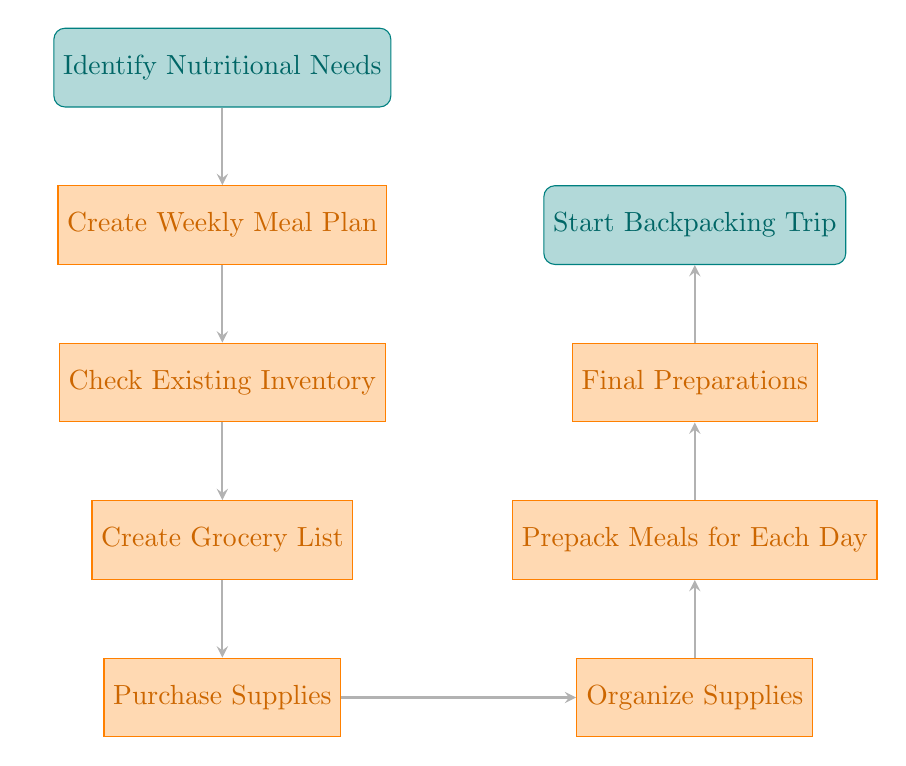What is the first step in the workflow? The first step in the workflow is the node labeled "Identify Nutritional Needs," which indicates the initial action to be taken.
Answer: Identify Nutritional Needs How many nodes are there in the diagram? By counting the nodes listed in the diagram (from start to end), we find there are a total of eight nodes.
Answer: Eight What is the last step before starting the trip? The last step before starting the trip is "Final Preparations," which occurs just before the action of actually starting the trip.
Answer: Final Preparations Which node follows "Create Grocery List"? Following "Create Grocery List," the next node is "Purchase Supplies," indicating the subsequent action taken after listing grocery needs.
Answer: Purchase Supplies What happens after checking existing inventory? After checking existing inventory, the process moves to "Create Grocery List," showing the flow from one step to the next according to the workflow.
Answer: Create Grocery List Which two nodes have a direct relationship as the next steps? "Organize Supplies" and "Prepack Meals for Each Day" have a direct relationship as they are sequential steps in the meal preparation workflow.
Answer: Organize Supplies and Prepack Meals for Each Day What is the purpose of "Purchase Supplies"? The purpose of "Purchase Supplies" is to obtain necessary ingredients and items based on the prior meal plan and grocery list.
Answer: Obtain necessary items In what order do the following nodes appear: "Create Weekly Meal Plan," "Check Existing Inventory," and "Prepack Meals for Each Day"? The order of these nodes, as shown in the diagram, is: "Create Weekly Meal Plan" first, then "Check Existing Inventory," followed by "Prepack Meals for Each Day," indicating a logical flow from planning to preparation.
Answer: Create Weekly Meal Plan, Check Existing Inventory, Prepack Meals for Each Day 